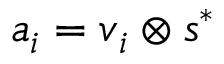<formula> <loc_0><loc_0><loc_500><loc_500>a _ { i } = v _ { i } \otimes s ^ { * }</formula> 